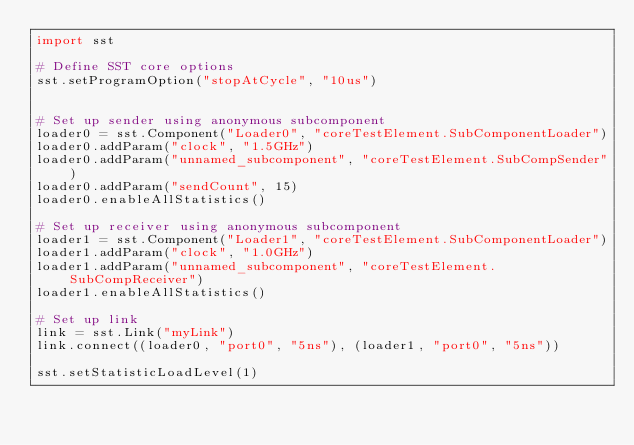Convert code to text. <code><loc_0><loc_0><loc_500><loc_500><_Python_>import sst

# Define SST core options
sst.setProgramOption("stopAtCycle", "10us")


# Set up sender using anonymous subcomponent
loader0 = sst.Component("Loader0", "coreTestElement.SubComponentLoader")
loader0.addParam("clock", "1.5GHz")
loader0.addParam("unnamed_subcomponent", "coreTestElement.SubCompSender")
loader0.addParam("sendCount", 15)
loader0.enableAllStatistics()

# Set up receiver using anonymous subcomponent
loader1 = sst.Component("Loader1", "coreTestElement.SubComponentLoader")
loader1.addParam("clock", "1.0GHz")
loader1.addParam("unnamed_subcomponent", "coreTestElement.SubCompReceiver")
loader1.enableAllStatistics()

# Set up link
link = sst.Link("myLink")
link.connect((loader0, "port0", "5ns"), (loader1, "port0", "5ns"))

sst.setStatisticLoadLevel(1)
</code> 